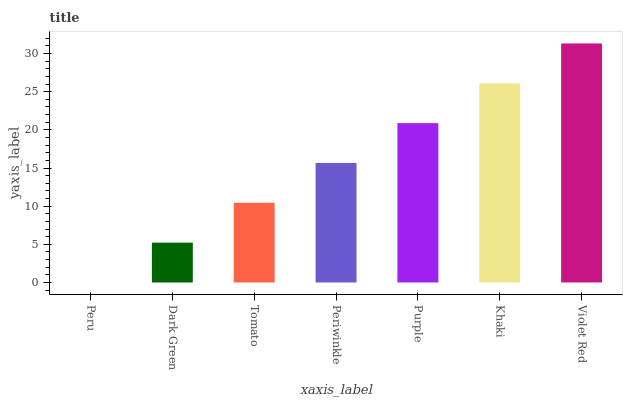Is Peru the minimum?
Answer yes or no. Yes. Is Violet Red the maximum?
Answer yes or no. Yes. Is Dark Green the minimum?
Answer yes or no. No. Is Dark Green the maximum?
Answer yes or no. No. Is Dark Green greater than Peru?
Answer yes or no. Yes. Is Peru less than Dark Green?
Answer yes or no. Yes. Is Peru greater than Dark Green?
Answer yes or no. No. Is Dark Green less than Peru?
Answer yes or no. No. Is Periwinkle the high median?
Answer yes or no. Yes. Is Periwinkle the low median?
Answer yes or no. Yes. Is Khaki the high median?
Answer yes or no. No. Is Purple the low median?
Answer yes or no. No. 